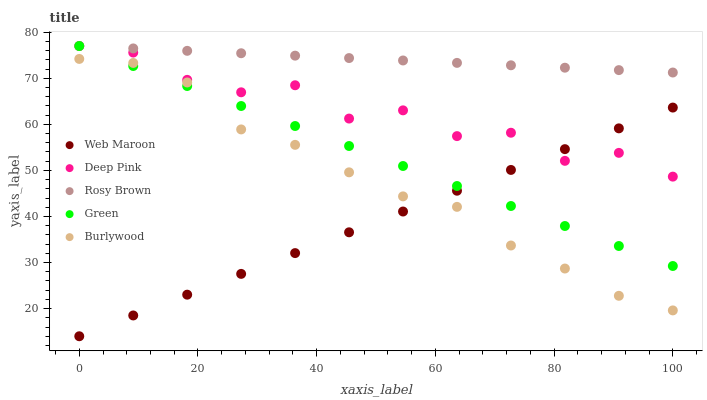Does Web Maroon have the minimum area under the curve?
Answer yes or no. Yes. Does Rosy Brown have the maximum area under the curve?
Answer yes or no. Yes. Does Green have the minimum area under the curve?
Answer yes or no. No. Does Green have the maximum area under the curve?
Answer yes or no. No. Is Web Maroon the smoothest?
Answer yes or no. Yes. Is Deep Pink the roughest?
Answer yes or no. Yes. Is Green the smoothest?
Answer yes or no. No. Is Green the roughest?
Answer yes or no. No. Does Web Maroon have the lowest value?
Answer yes or no. Yes. Does Green have the lowest value?
Answer yes or no. No. Does Deep Pink have the highest value?
Answer yes or no. Yes. Does Web Maroon have the highest value?
Answer yes or no. No. Is Burlywood less than Rosy Brown?
Answer yes or no. Yes. Is Rosy Brown greater than Burlywood?
Answer yes or no. Yes. Does Green intersect Web Maroon?
Answer yes or no. Yes. Is Green less than Web Maroon?
Answer yes or no. No. Is Green greater than Web Maroon?
Answer yes or no. No. Does Burlywood intersect Rosy Brown?
Answer yes or no. No. 